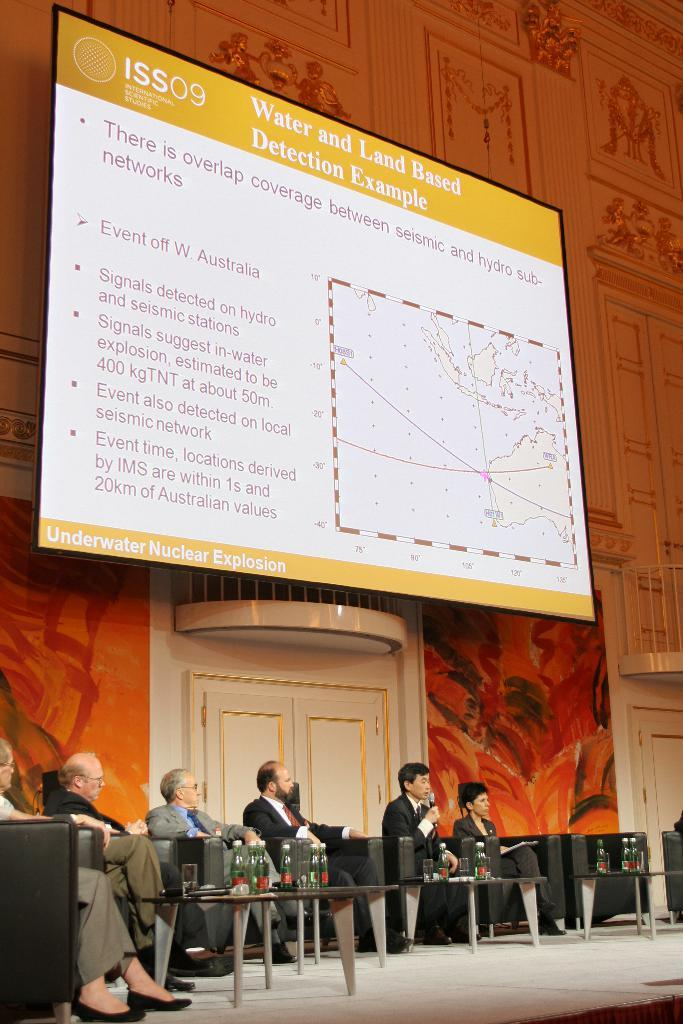What are the people in the image doing? The people in the image are sitting on chairs. Where are the people sitting in relation to the tables? The people are behind the tables. What can be seen on the tables in the image? There are water bottles on the tables. What is above the tables in the image? There is a big screen above the tables. What is being displayed on the big screen? The big screen displays ISSO content. Can you tell me how many moms are present in the image? There is no mention of a mom or any parental figure in the image. What type of pail is being used by the people in the image? There is no pail present in the image. 